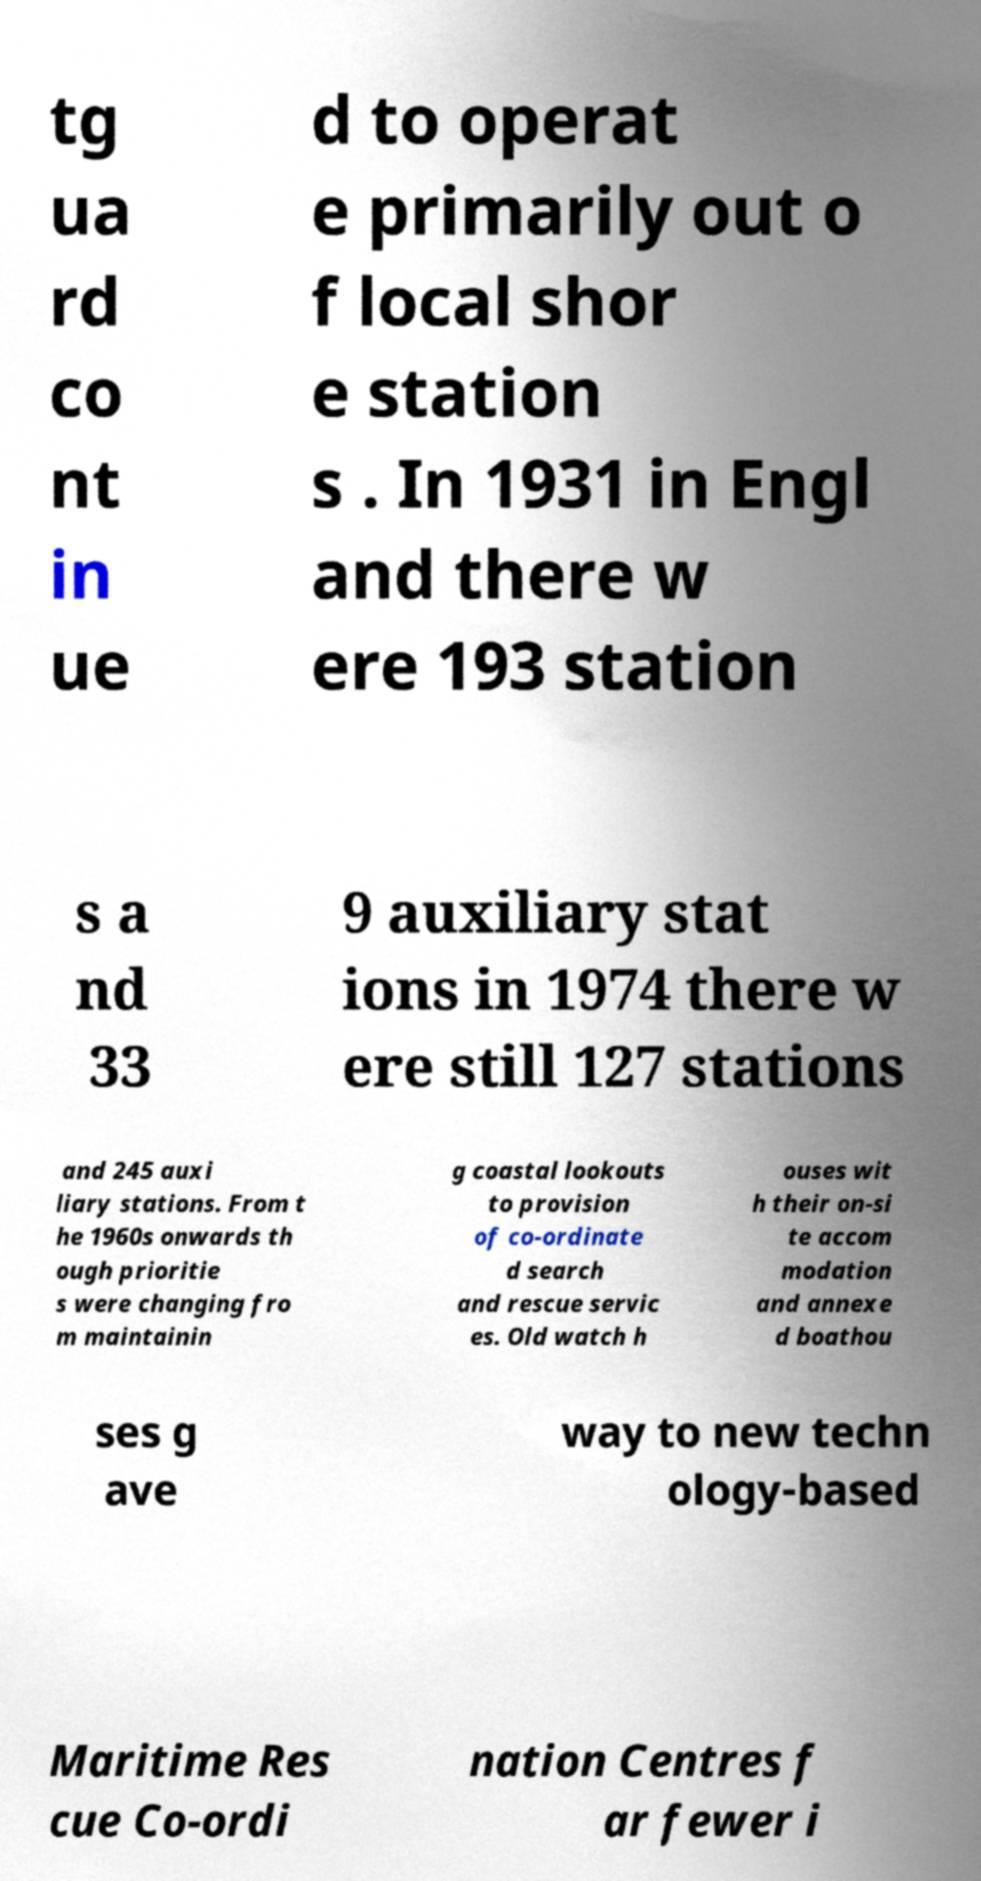For documentation purposes, I need the text within this image transcribed. Could you provide that? tg ua rd co nt in ue d to operat e primarily out o f local shor e station s . In 1931 in Engl and there w ere 193 station s a nd 33 9 auxiliary stat ions in 1974 there w ere still 127 stations and 245 auxi liary stations. From t he 1960s onwards th ough prioritie s were changing fro m maintainin g coastal lookouts to provision of co-ordinate d search and rescue servic es. Old watch h ouses wit h their on-si te accom modation and annexe d boathou ses g ave way to new techn ology-based Maritime Res cue Co-ordi nation Centres f ar fewer i 